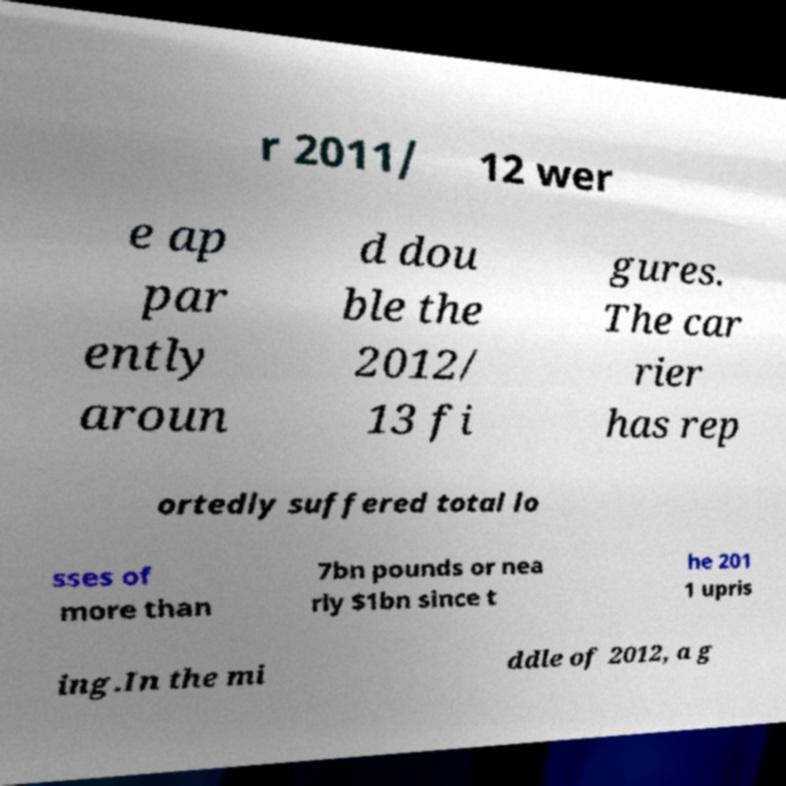What messages or text are displayed in this image? I need them in a readable, typed format. r 2011/ 12 wer e ap par ently aroun d dou ble the 2012/ 13 fi gures. The car rier has rep ortedly suffered total lo sses of more than 7bn pounds or nea rly $1bn since t he 201 1 upris ing.In the mi ddle of 2012, a g 